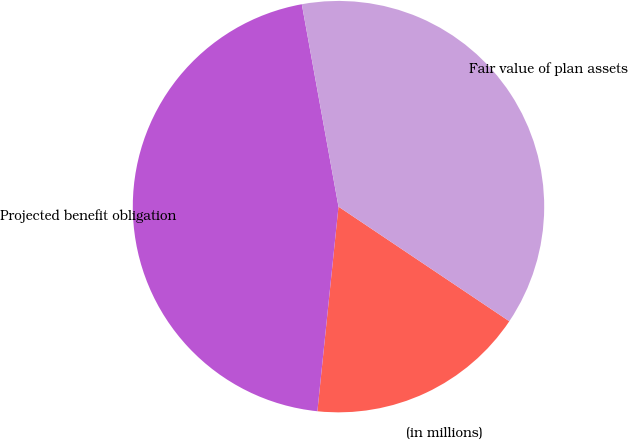<chart> <loc_0><loc_0><loc_500><loc_500><pie_chart><fcel>(in millions)<fcel>Projected benefit obligation<fcel>Fair value of plan assets<nl><fcel>17.23%<fcel>45.51%<fcel>37.26%<nl></chart> 